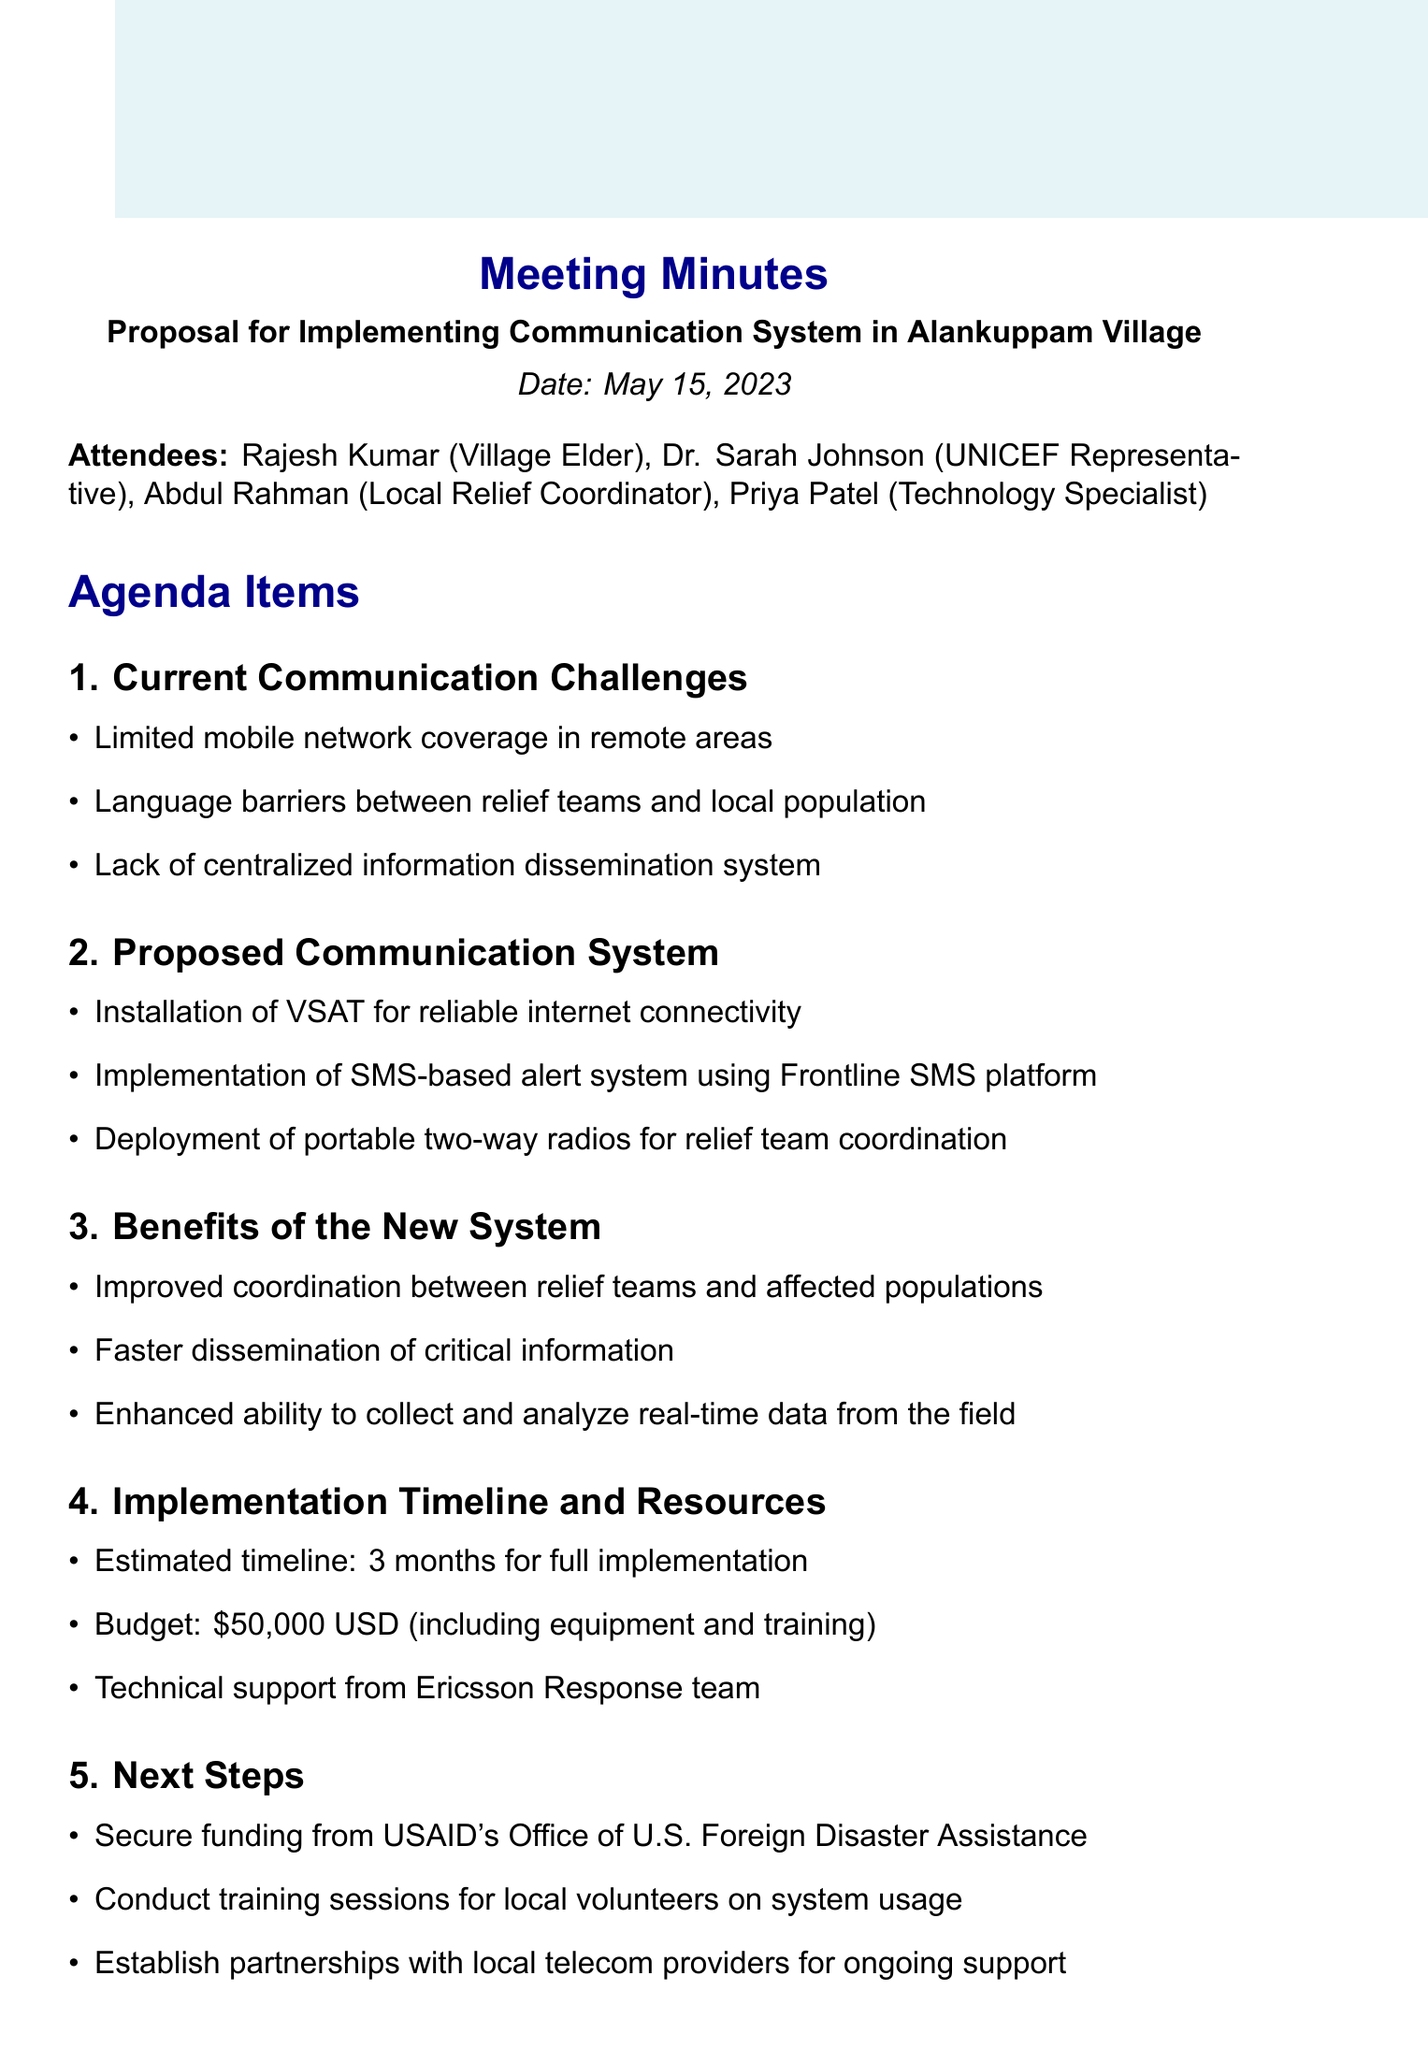What is the date of the meeting? The meeting date is specifically mentioned at the beginning of the document.
Answer: May 15, 2023 Who is the local relief coordinator? The name of the local relief coordinator is listed under attendees.
Answer: Abdul Rahman What is the estimated budget for the proposed communication system? The budget is detailed in the implementation timeline and resources section of the document.
Answer: $50,000 USD What is one of the current communication challenges identified in the meeting? Current challenges are listed under the agenda items of the document.
Answer: Limited mobile network coverage in remote areas What is the proposed method for improving information dissemination? The proposed communication system contains various methods for facilitating communication, which is noted in the corresponding section.
Answer: SMS-based alert system using Frontline SMS platform What is the deadline for organizing the community feedback session? The deadlines for action items are listed clearly in the action items section.
Answer: June 10, 2023 How long is the estimated timeline for full implementation of the communication system? The estimated timeline is indicated in the implementation timeline and resources section.
Answer: 3 months Who is tasked with drafting the detailed project proposal? The individual responsible for this action item is specified in the action items section.
Answer: Abdul Rahman 